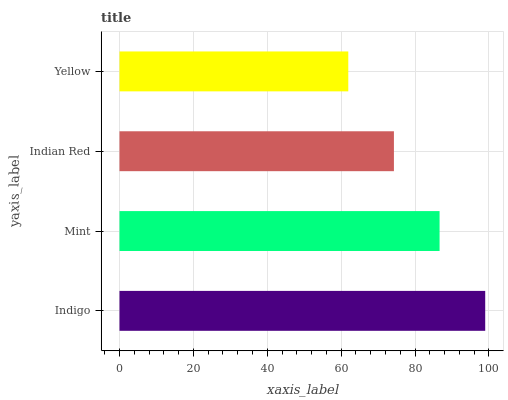Is Yellow the minimum?
Answer yes or no. Yes. Is Indigo the maximum?
Answer yes or no. Yes. Is Mint the minimum?
Answer yes or no. No. Is Mint the maximum?
Answer yes or no. No. Is Indigo greater than Mint?
Answer yes or no. Yes. Is Mint less than Indigo?
Answer yes or no. Yes. Is Mint greater than Indigo?
Answer yes or no. No. Is Indigo less than Mint?
Answer yes or no. No. Is Mint the high median?
Answer yes or no. Yes. Is Indian Red the low median?
Answer yes or no. Yes. Is Indian Red the high median?
Answer yes or no. No. Is Mint the low median?
Answer yes or no. No. 